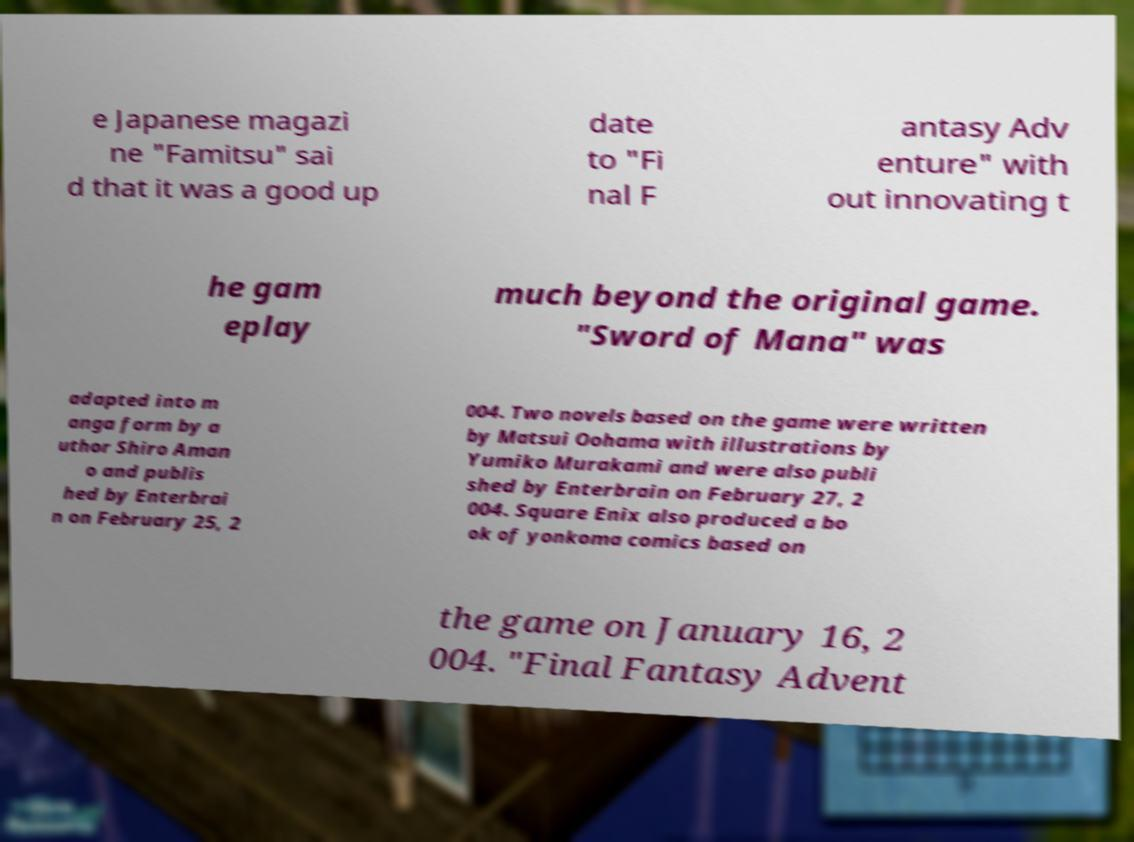Could you extract and type out the text from this image? e Japanese magazi ne "Famitsu" sai d that it was a good up date to "Fi nal F antasy Adv enture" with out innovating t he gam eplay much beyond the original game. "Sword of Mana" was adapted into m anga form by a uthor Shiro Aman o and publis hed by Enterbrai n on February 25, 2 004. Two novels based on the game were written by Matsui Oohama with illustrations by Yumiko Murakami and were also publi shed by Enterbrain on February 27, 2 004. Square Enix also produced a bo ok of yonkoma comics based on the game on January 16, 2 004. "Final Fantasy Advent 